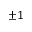Convert formula to latex. <formula><loc_0><loc_0><loc_500><loc_500>\pm 1</formula> 